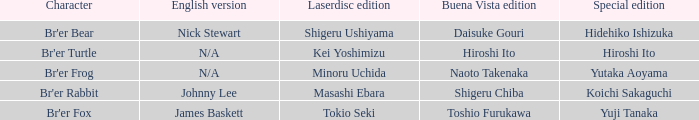Who is the buena vista edidtion where special edition is koichi sakaguchi? Shigeru Chiba. 